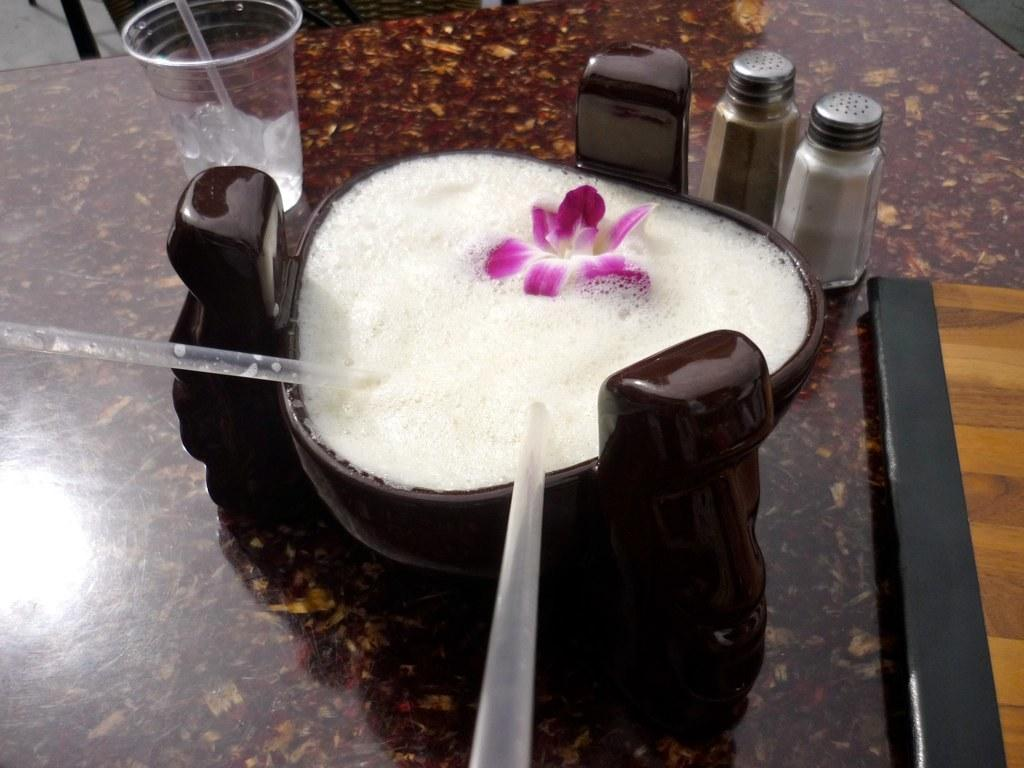What is contained within the bowl in the image? There is a bowl with liquid in the image. What is floating in the liquid? There is a flower in the bowl. What can be used to drink the liquid in the bowl? There are straws in the bowl. What is another container for liquid visible in the image? There is a glass in the image. What else related to liquid storage is present in the image? There are bottles on the table. Can you see the moon in the image? No, the moon is not present in the image. 